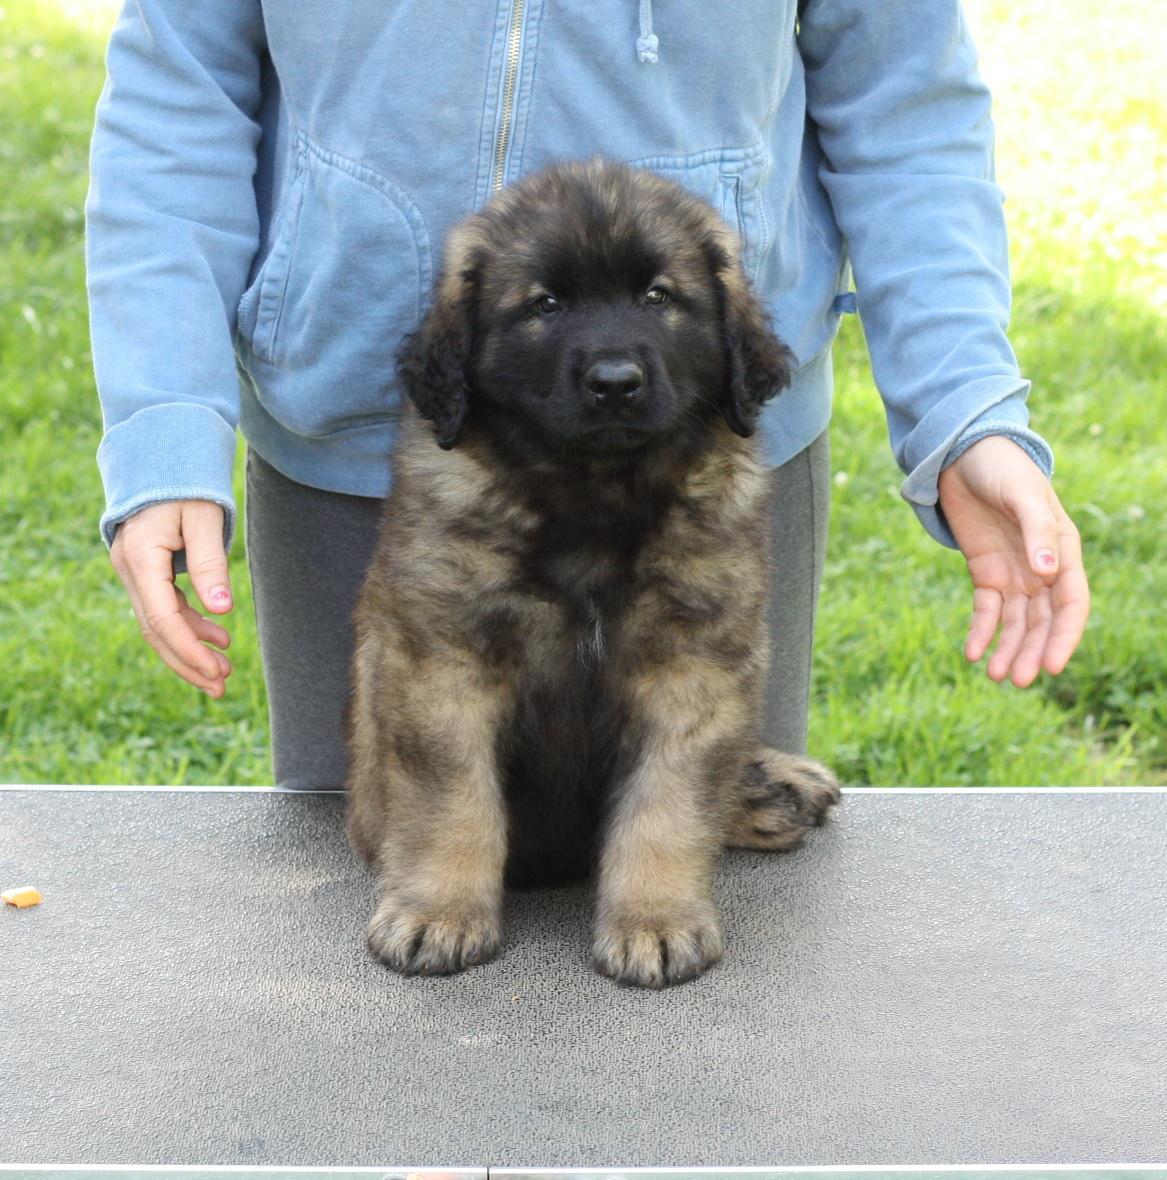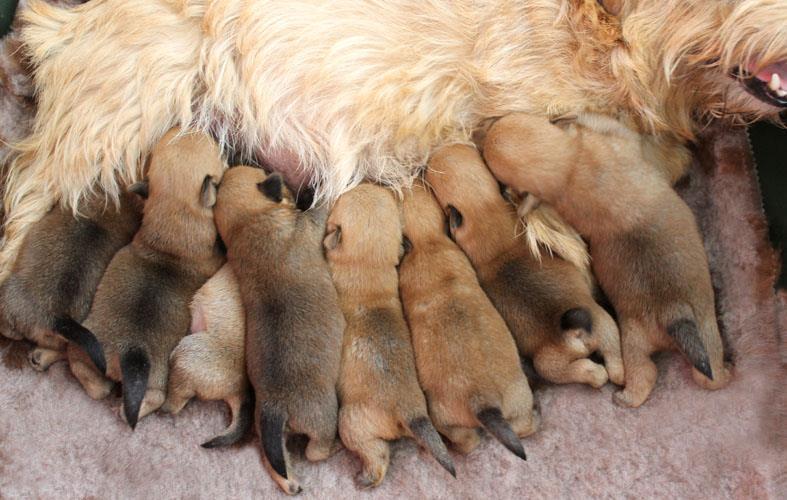The first image is the image on the left, the second image is the image on the right. Examine the images to the left and right. Is the description "The dog on the right is nursing a pile of brown puppies, while the dog on the left is all alone, and an image shows a wood frame forming a corner around a dog." accurate? Answer yes or no. No. The first image is the image on the left, the second image is the image on the right. Evaluate the accuracy of this statement regarding the images: "An adult dog is lying on her side with front legs extended outward while her puppies crowd in to nurse, while a second image shows a large dog lying on a floor.". Is it true? Answer yes or no. No. 